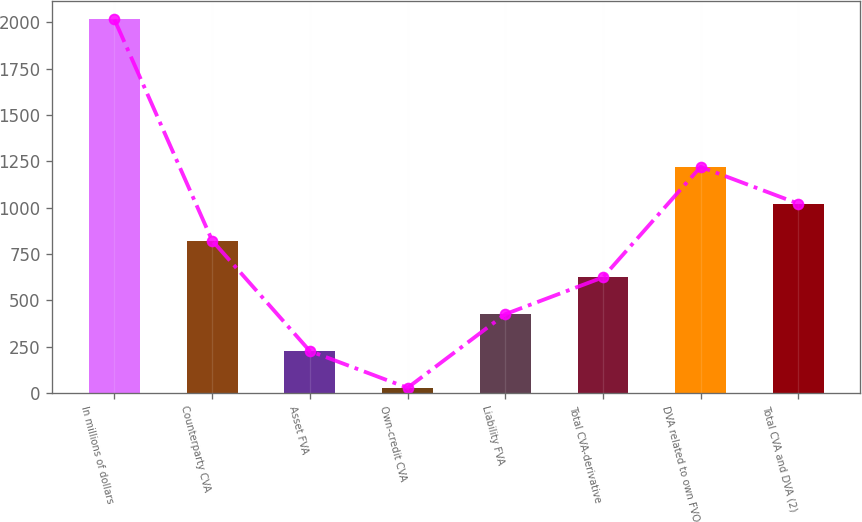Convert chart. <chart><loc_0><loc_0><loc_500><loc_500><bar_chart><fcel>In millions of dollars<fcel>Counterparty CVA<fcel>Asset FVA<fcel>Own-credit CVA<fcel>Liability FVA<fcel>Total CVA-derivative<fcel>DVA related to own FVO<fcel>Total CVA and DVA (2)<nl><fcel>2015<fcel>822.8<fcel>226.7<fcel>28<fcel>425.4<fcel>624.1<fcel>1220.2<fcel>1021.5<nl></chart> 